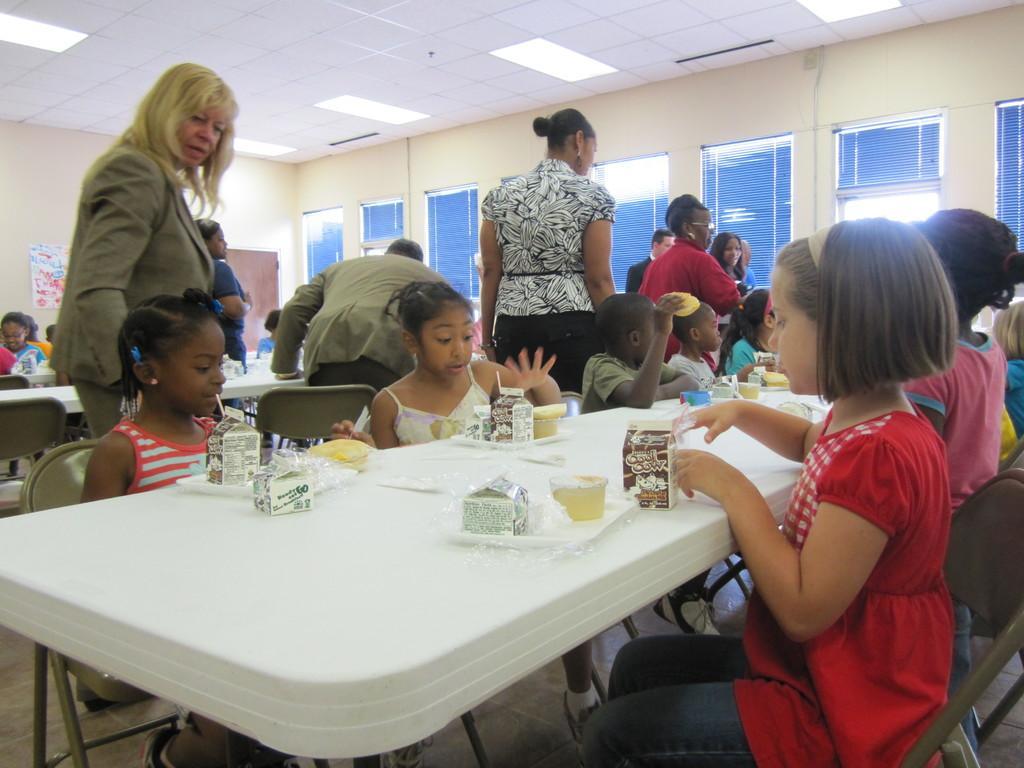Describe this image in one or two sentences. In the middle of the image there is a table, On the table there are some food products. Surrounding the table few people are sitting. In the middle of the image few people are standing and watching. Top right side of the image there is a wall and there are some windows. At the top of the image there is a roof and lights. 